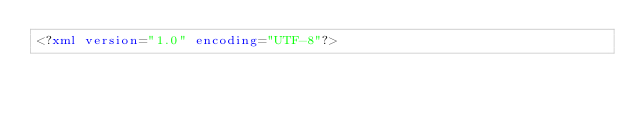<code> <loc_0><loc_0><loc_500><loc_500><_XML_><?xml version="1.0" encoding="UTF-8"?></code> 